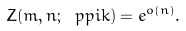Convert formula to latex. <formula><loc_0><loc_0><loc_500><loc_500>Z ( m , n ; \ p p i k ) = e ^ { o ( n ) } .</formula> 